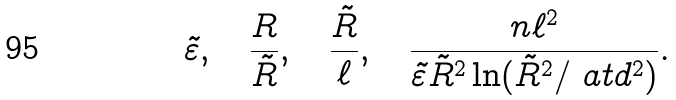<formula> <loc_0><loc_0><loc_500><loc_500>\tilde { \varepsilon } , \quad \frac { R } { \tilde { R } } , \quad \frac { \tilde { R } } { \ell } , \quad \frac { n \ell ^ { 2 } } { \tilde { \varepsilon } \tilde { R } ^ { 2 } \ln ( \tilde { R } ^ { 2 } / \ a t d ^ { 2 } ) } .</formula> 